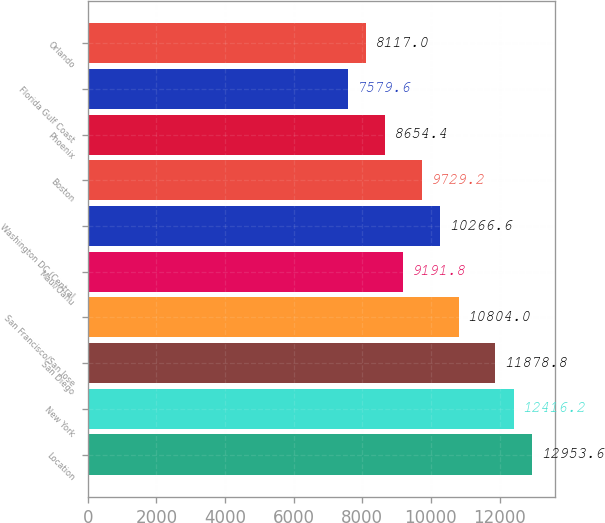<chart> <loc_0><loc_0><loc_500><loc_500><bar_chart><fcel>Location<fcel>New York<fcel>San Diego<fcel>San Francisco/San Jose<fcel>Maui/Oahu<fcel>Washington DC (Central<fcel>Boston<fcel>Phoenix<fcel>Florida Gulf Coast<fcel>Orlando<nl><fcel>12953.6<fcel>12416.2<fcel>11878.8<fcel>10804<fcel>9191.8<fcel>10266.6<fcel>9729.2<fcel>8654.4<fcel>7579.6<fcel>8117<nl></chart> 